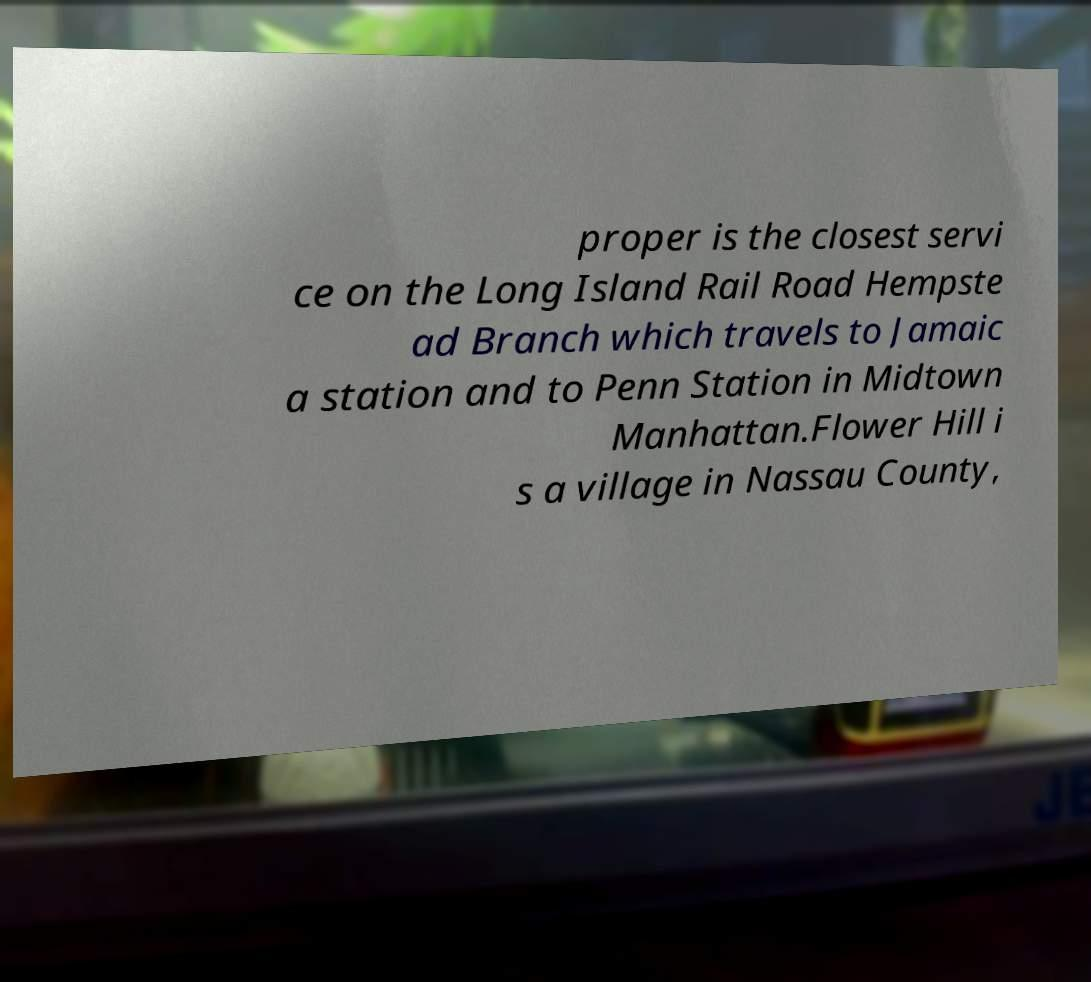Could you assist in decoding the text presented in this image and type it out clearly? proper is the closest servi ce on the Long Island Rail Road Hempste ad Branch which travels to Jamaic a station and to Penn Station in Midtown Manhattan.Flower Hill i s a village in Nassau County, 